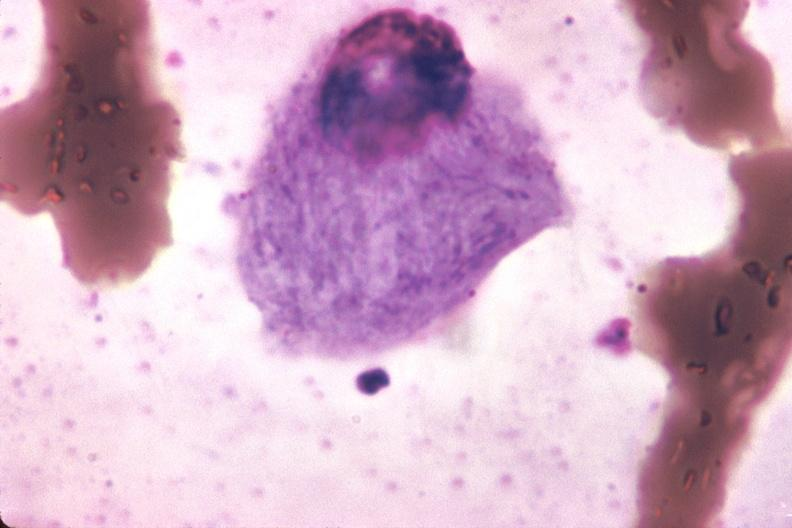s acid present?
Answer the question using a single word or phrase. No 